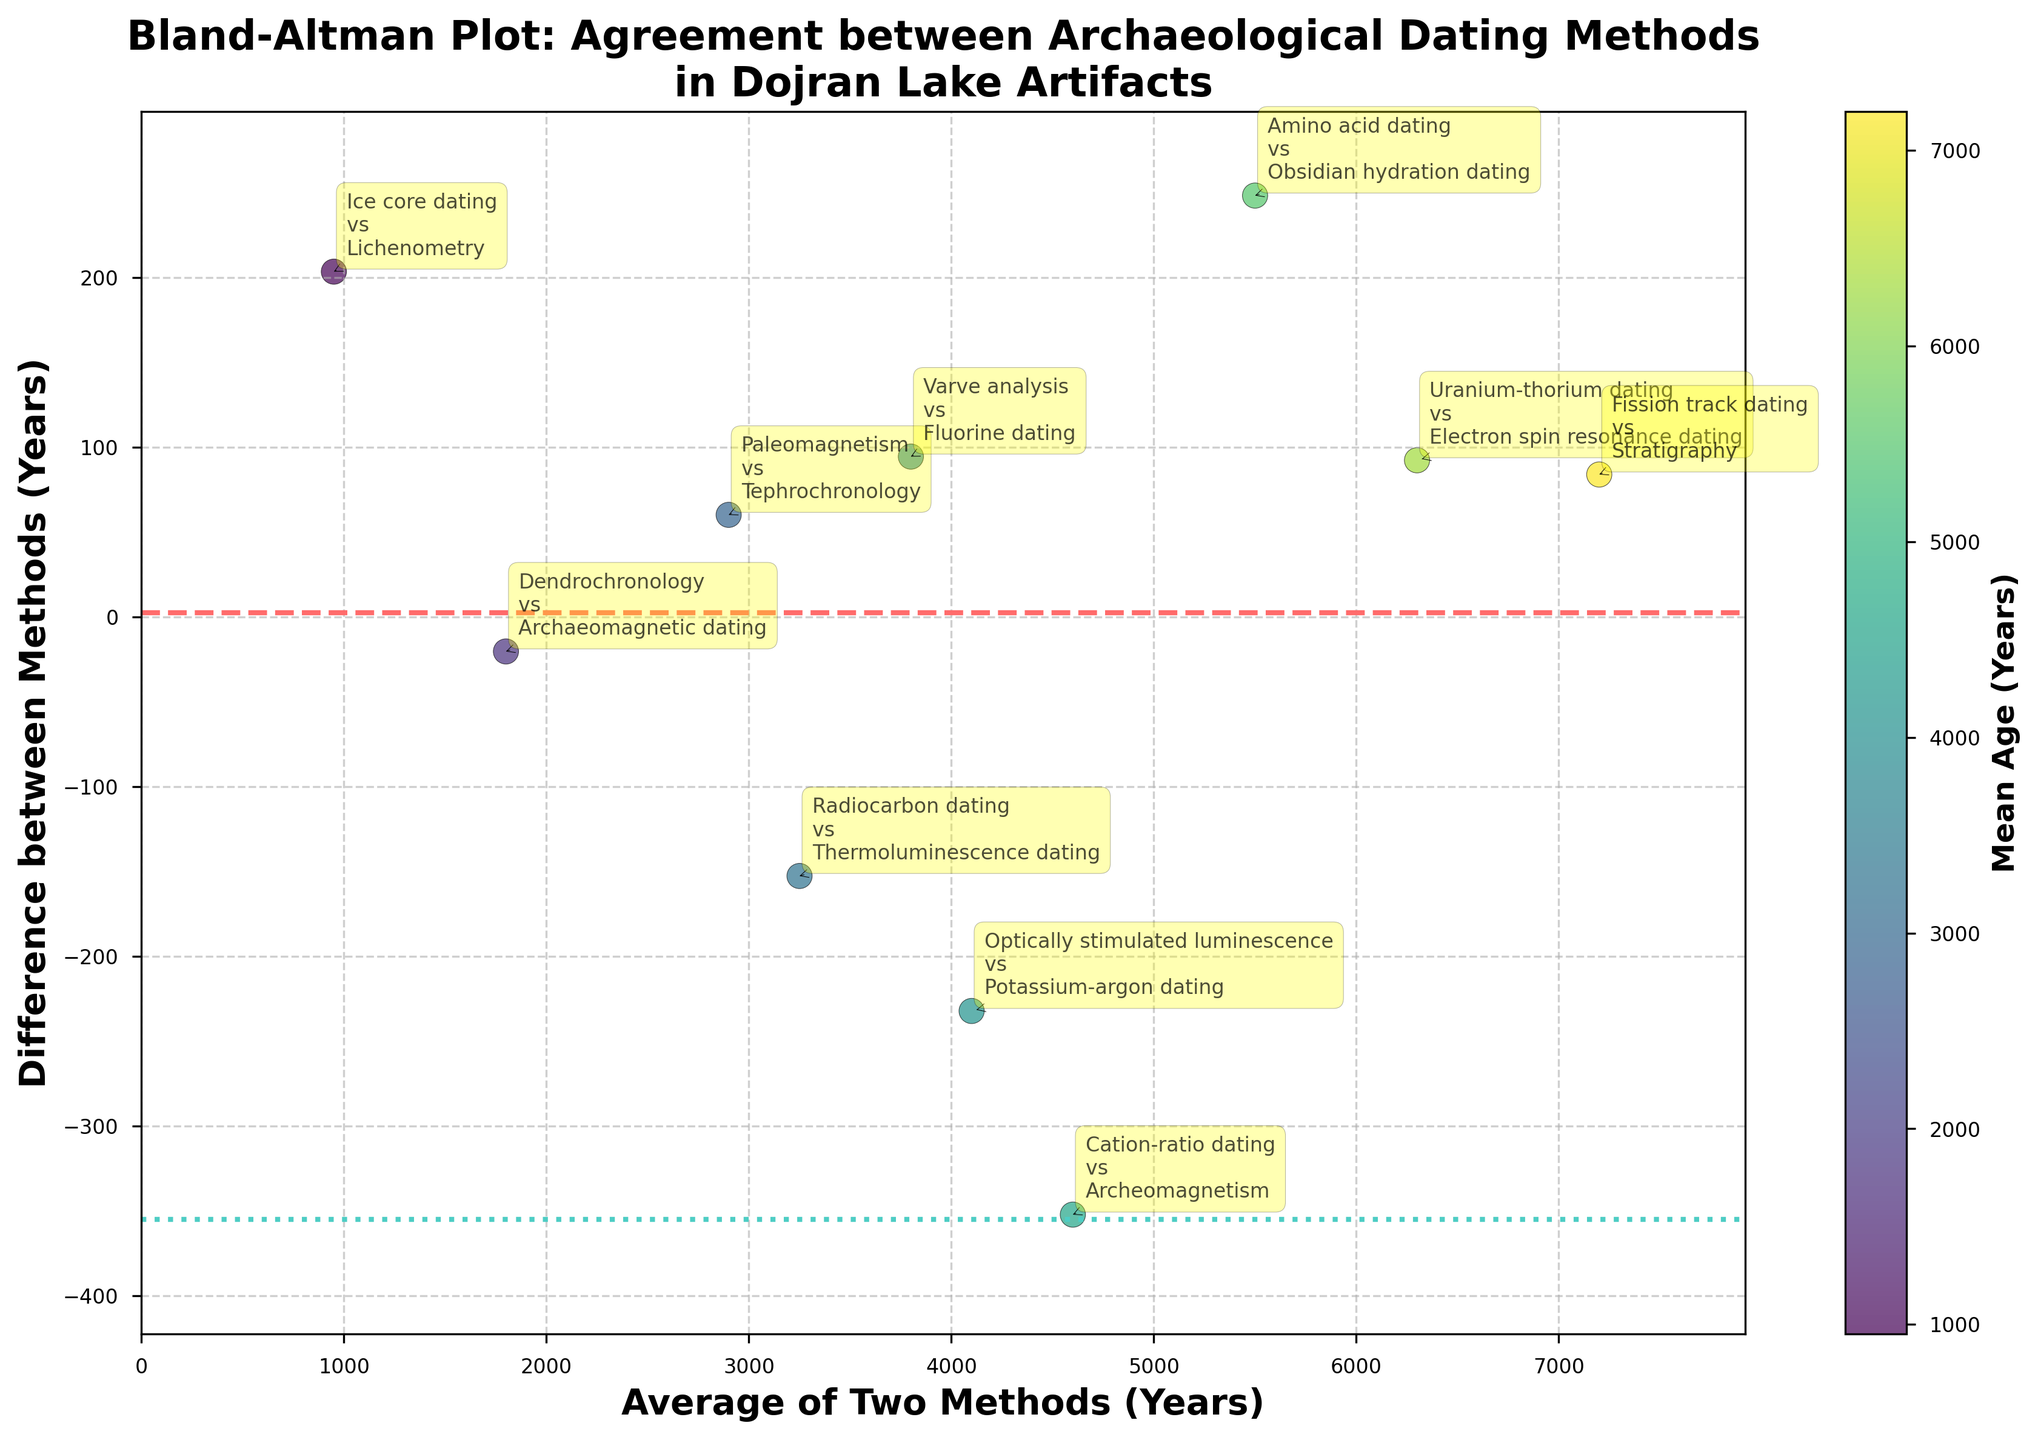How many data points are plotted in the figure? By counting the annotated method pairs in the Bland-Altman plot, we can determine the number of data points. Each methodological comparison is represented once.
Answer: 10 What is the title of the figure? The title is typically placed at the top of the figure, providing an overview of the subject being visualized.
Answer: Bland-Altman Plot: Agreement between Archaeological Dating Methods in Dojran Lake Artifacts Which axis represents the average of the two methods? The label of the horizontal axis in the figure usually indicates what it represents. In this case, it is labeled "Average of Two Methods (Years)".
Answer: The horizontal axis Which axis represents the difference between the two methods? Looking at the vertical axis label will show what it represents. Here it is labeled "Difference between Methods (Years)".
Answer: The vertical axis What methods have the lowest average age? By examining the position of data points along the horizontal axis, identify the ones closest to the origin or 0. The methods near the lowest x-value have the lowest average.
Answer: Ice core dating vs. Lichenometry Which methods show the largest difference between their dating results? Identify the point farthest away on the vertical axis from the horizontal line marked by mean difference. This difference will be the most extreme.
Answer: Fission track dating vs. Stratigraphy What's the mean difference between methods based on the plot? The horizontal dashed line plotted on the Bland-Altman plot represents the mean difference between the methods. Its value is usually given or can be interpolated from its position.
Answer: Approximately 0 What is the range of differences that are within ±1.96 times the standard deviation from the mean difference? The lines plotted above and below the mean difference line in the Bland-Altman plot indicate ±1.96 times the standard deviation. The range is the vertical distance between these two lines.
Answer: Approximately -392 to 392 How is the color of the data points determined? The colorbar on the right side of the plot indicates the mapping between color and the mean age of the artifact according to the methods. The color corresponds to this value.
Answer: By the mean age of the artifact Which method has the highest average age, and what is the corresponding color? Identify the farthest right point on the horizontal axis for the highest average. Then, refer to the color of that point using the colorbar.
Answer: Fission track dating vs. Stratigraphy, dark purple 